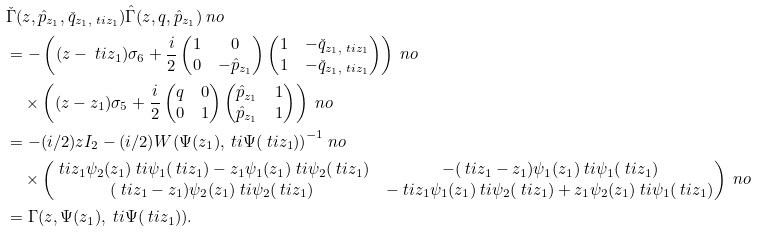<formula> <loc_0><loc_0><loc_500><loc_500>& \check { \Gamma } ( z , \hat { p } _ { z _ { 1 } } , \check { q } _ { z _ { 1 } , \ t i z _ { 1 } } ) \hat { \Gamma } ( z , q , \hat { p } _ { z _ { 1 } } ) \ n o \\ & = - \left ( ( z - \ t i z _ { 1 } ) \sigma _ { 6 } + \frac { i } { 2 } \begin{pmatrix} 1 & 0 \\ 0 & - \hat { p } _ { z _ { 1 } } \end{pmatrix} \begin{pmatrix} 1 & - \check { q } _ { z _ { 1 } , \ t i z _ { 1 } } \\ 1 & - \check { q } _ { z _ { 1 } , \ t i z _ { 1 } } \end{pmatrix} \right ) \ n o \\ & \quad \times \left ( ( z - z _ { 1 } ) \sigma _ { 5 } + \frac { i } { 2 } \begin{pmatrix} q & 0 \\ 0 & 1 \end{pmatrix} \begin{pmatrix} \hat { p } _ { z _ { 1 } } & 1 \\ \hat { p } _ { z _ { 1 } } & 1 \end{pmatrix} \right ) \ n o \\ & = - ( i / 2 ) z I _ { 2 } - ( i / 2 ) { W ( \Psi ( z _ { 1 } ) , \ t i \Psi ( \ t i z _ { 1 } ) ) } ^ { - 1 } \ n o \\ & \quad \times \begin{pmatrix} \ t i z _ { 1 } \psi _ { 2 } ( z _ { 1 } ) \ t i \psi _ { 1 } ( \ t i z _ { 1 } ) - z _ { 1 } \psi _ { 1 } ( z _ { 1 } ) \ t i \psi _ { 2 } ( \ t i z _ { 1 } ) & - ( \ t i z _ { 1 } - z _ { 1 } ) \psi _ { 1 } ( z _ { 1 } ) \ t i \psi _ { 1 } ( \ t i z _ { 1 } ) \\ ( \ t i z _ { 1 } - z _ { 1 } ) \psi _ { 2 } ( z _ { 1 } ) \ t i \psi _ { 2 } ( \ t i z _ { 1 } ) & - \ t i z _ { 1 } \psi _ { 1 } ( z _ { 1 } ) \ t i \psi _ { 2 } ( \ t i z _ { 1 } ) + z _ { 1 } \psi _ { 2 } ( z _ { 1 } ) \ t i \psi _ { 1 } ( \ t i z _ { 1 } ) \end{pmatrix} \ n o \\ & = \Gamma ( z , \Psi ( z _ { 1 } ) , \ t i \Psi ( \ t i z _ { 1 } ) ) .</formula> 